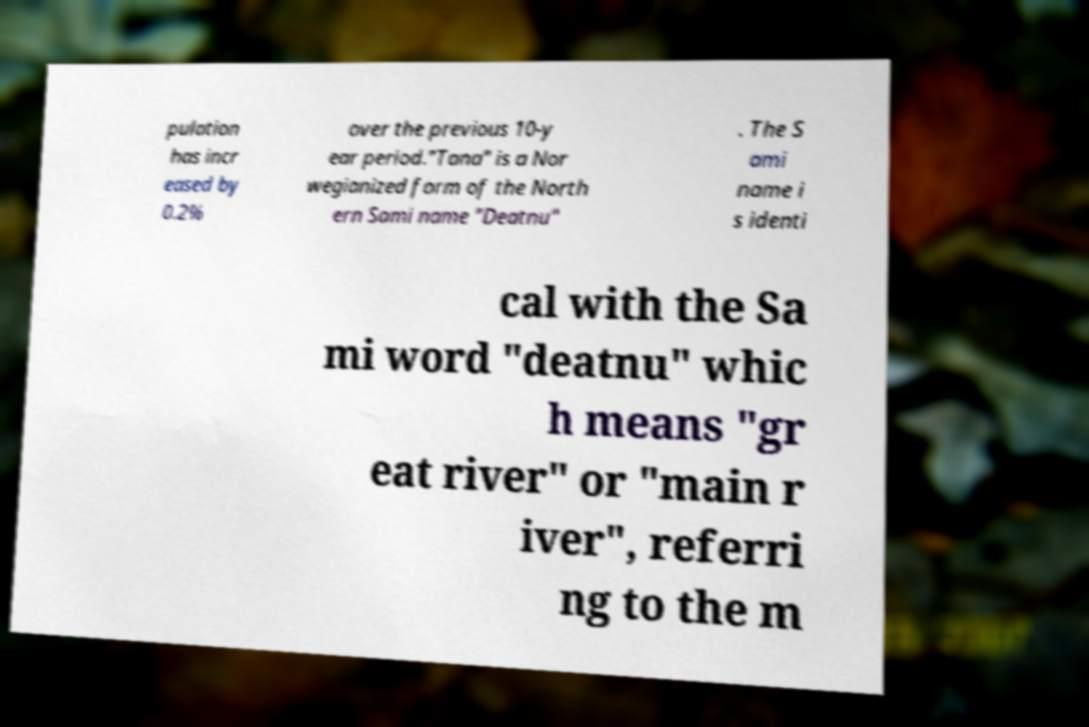Can you accurately transcribe the text from the provided image for me? pulation has incr eased by 0.2% over the previous 10-y ear period."Tana" is a Nor wegianized form of the North ern Sami name "Deatnu" . The S ami name i s identi cal with the Sa mi word "deatnu" whic h means "gr eat river" or "main r iver", referri ng to the m 